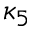<formula> <loc_0><loc_0><loc_500><loc_500>\kappa _ { 5 }</formula> 